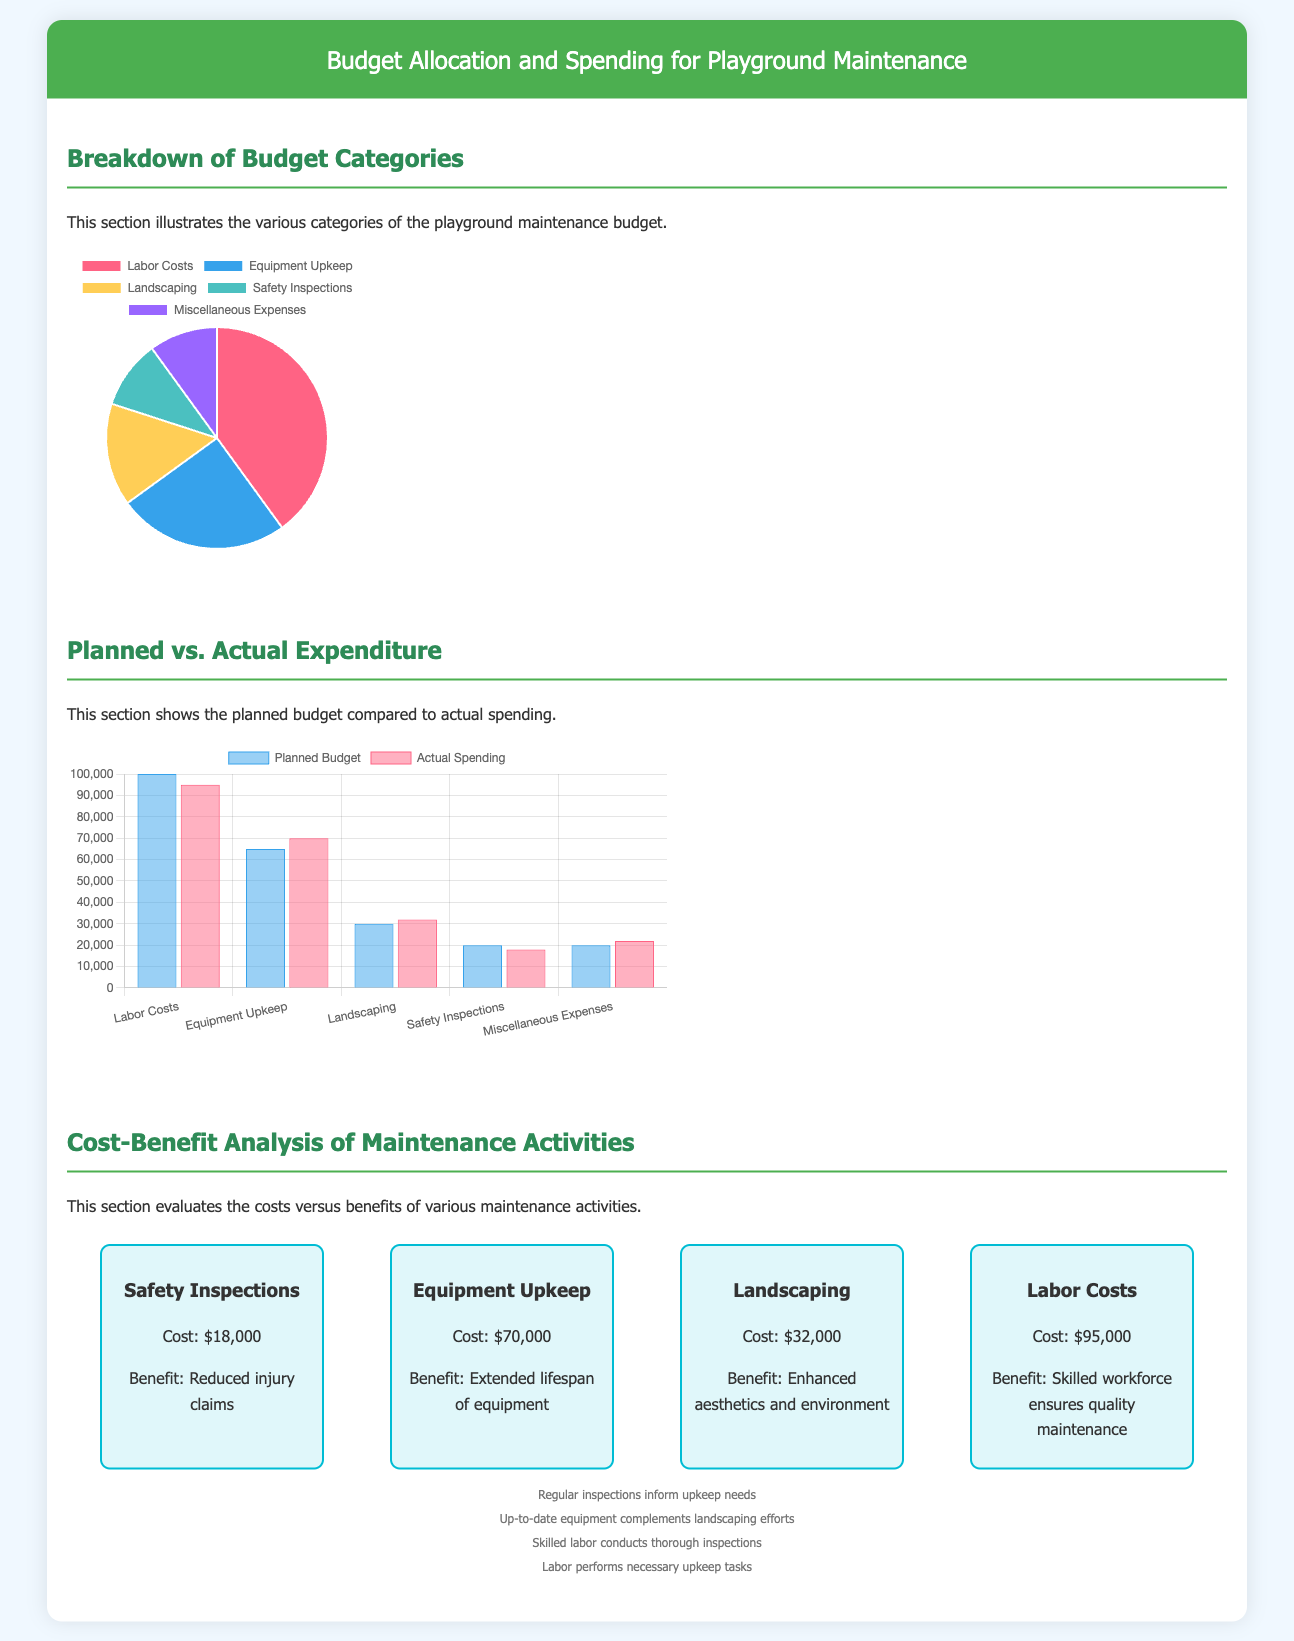What are the two main categories displayed in the budget pie chart? The pie chart displays various budget categories for playground maintenance, highlighting Labor Costs and Equipment Upkeep as the two most significant.
Answer: Labor Costs, Equipment Upkeep What was the planned budget for Labor Costs? The planned budget for Labor Costs is shown in the bar chart section. The value noted is $100,000.
Answer: $100,000 What is the actual expenditure for Safety Inspections? The actual expenditure for Safety Inspections is illustrated in the bar chart alongside planned spending, totaling $18,000.
Answer: $18,000 Which maintenance activity has the highest cost listed in the cost-benefit analysis? The cost-benefit analysis section presents Labor Costs as having the highest expenditure listed at $95,000.
Answer: Labor Costs What is the benefit of Equipment Upkeep mentioned in the analysis? Equipment Upkeep is noted to have the benefit of extending the lifespan of equipment, as indicated in the cost-benefit analysis.
Answer: Extended lifespan of equipment What percentage of the budget is allocated to Landscaping? The pie chart shows that Landscaping accounts for 15% of the total budget allocation for playground maintenance.
Answer: 15% How does the actual spending for Equipment Upkeep compare to the planned budget? The comparison from the bar chart illustrates that the actual spending for Equipment Upkeep is $70,000, which exceeds the planned budget of $65,000.
Answer: Actual spending exceeds planned budget What type of visual representation is used to display the planned vs actual expenditure? The document uses a bar chart to compare planned versus actual expenditure for various budget categories.
Answer: Bar chart 